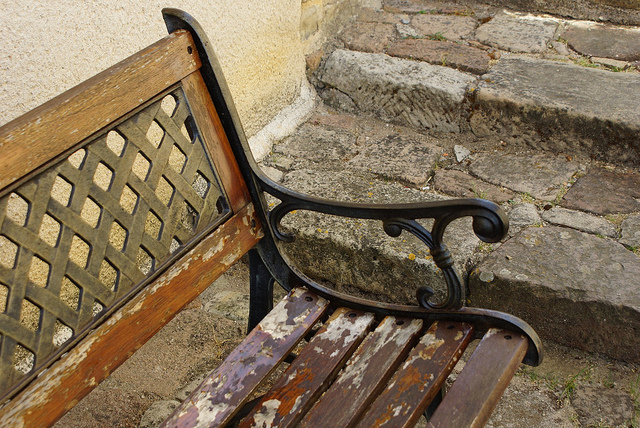Besides wood, what is the bench made of?
Answer the question using a single word or phrase. Metal Is the wood wearing off on this bench? Yes How many steps are visible? 2 